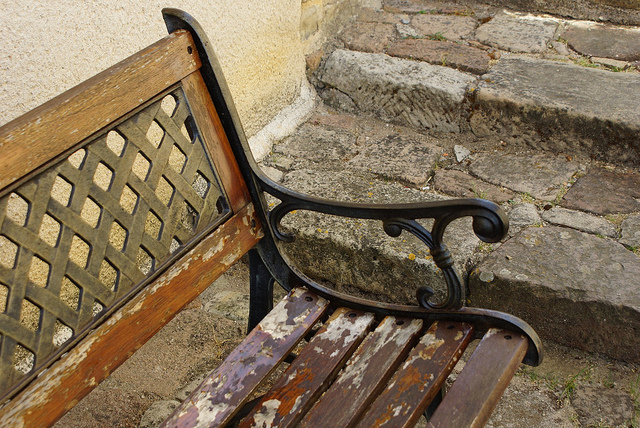Besides wood, what is the bench made of?
Answer the question using a single word or phrase. Metal Is the wood wearing off on this bench? Yes How many steps are visible? 2 